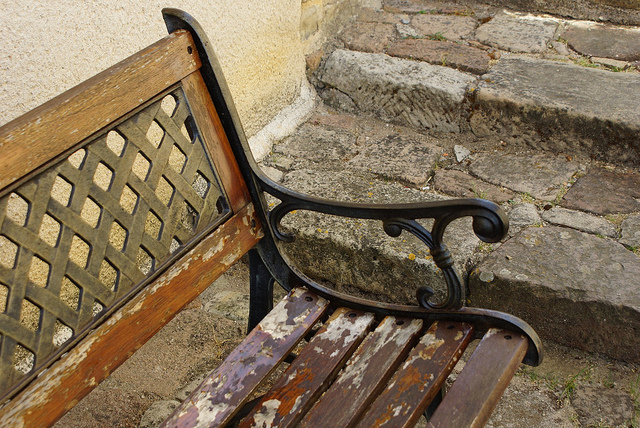Besides wood, what is the bench made of?
Answer the question using a single word or phrase. Metal Is the wood wearing off on this bench? Yes How many steps are visible? 2 